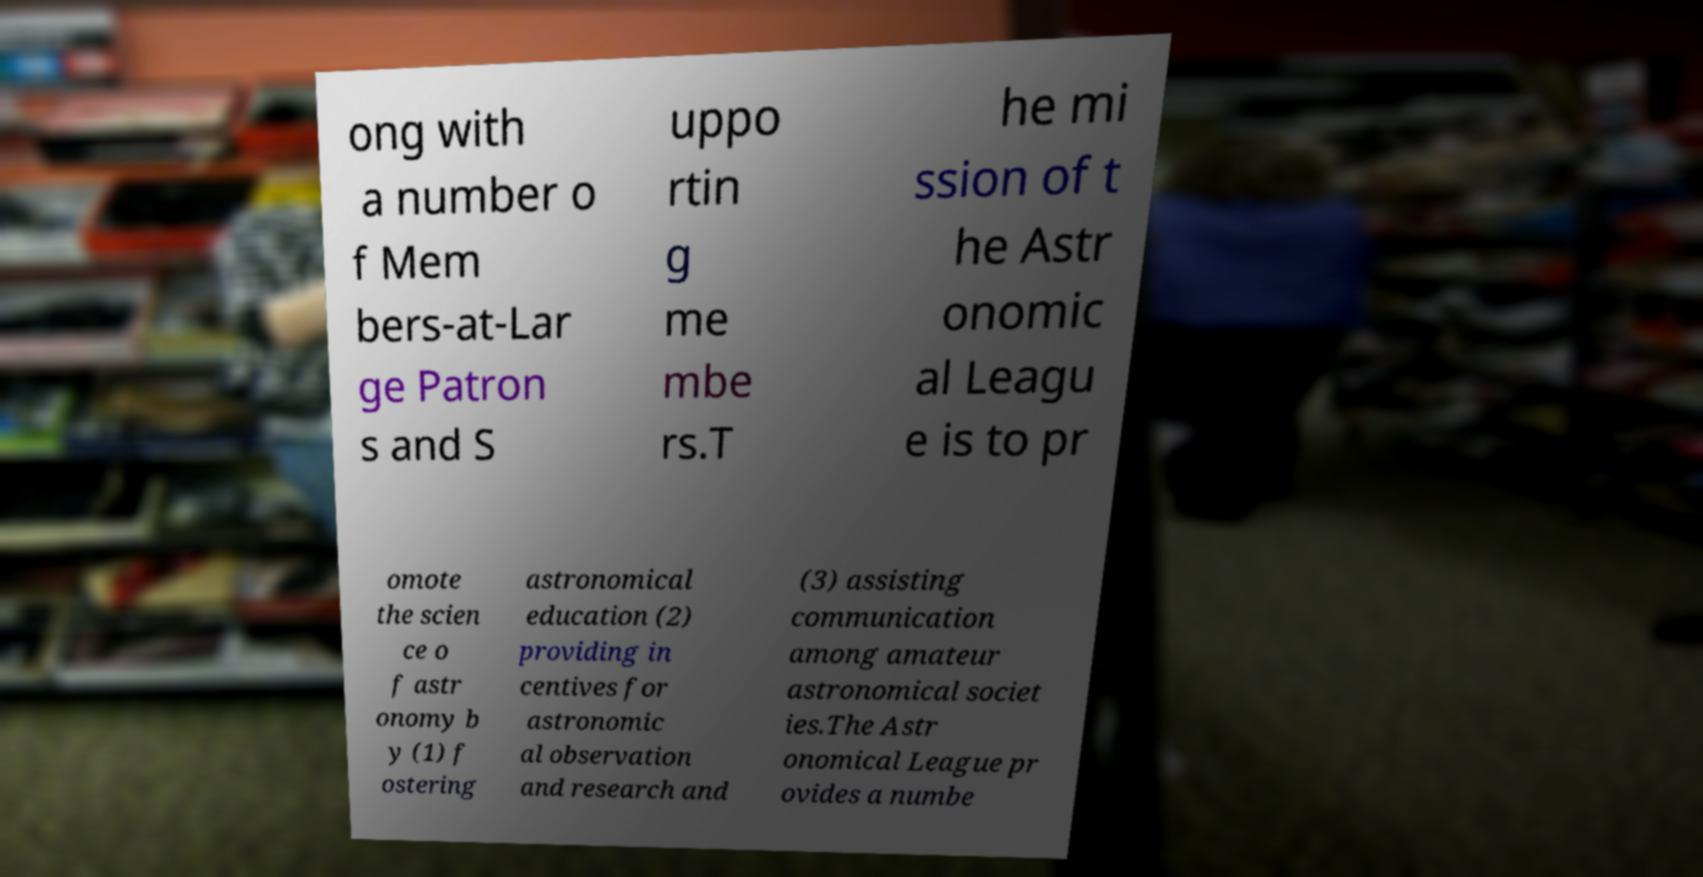Can you read and provide the text displayed in the image?This photo seems to have some interesting text. Can you extract and type it out for me? ong with a number o f Mem bers-at-Lar ge Patron s and S uppo rtin g me mbe rs.T he mi ssion of t he Astr onomic al Leagu e is to pr omote the scien ce o f astr onomy b y (1) f ostering astronomical education (2) providing in centives for astronomic al observation and research and (3) assisting communication among amateur astronomical societ ies.The Astr onomical League pr ovides a numbe 